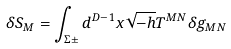<formula> <loc_0><loc_0><loc_500><loc_500>\delta S _ { M } = \int _ { \Sigma \pm } d ^ { D - 1 } x \sqrt { - h } T ^ { M N } \delta g _ { M N }</formula> 